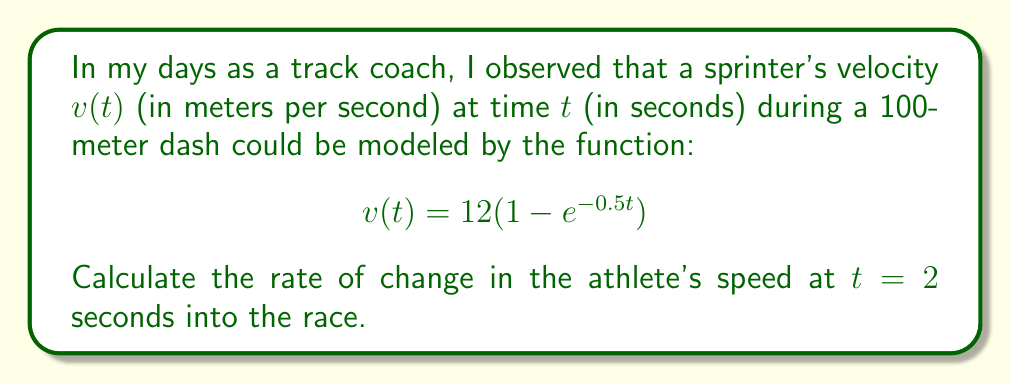Can you answer this question? To find the rate of change in the athlete's speed at $t = 2$ seconds, we need to calculate the derivative of the velocity function $v(t)$ and evaluate it at $t = 2$.

Step 1: Find the derivative of $v(t)$.
$$\begin{align}
v(t) &= 12(1 - e^{-0.5t}) \\
\frac{dv}{dt} &= 12 \cdot \frac{d}{dt}(1 - e^{-0.5t}) \\
&= 12 \cdot (-1) \cdot (-0.5e^{-0.5t}) \\
&= 6e^{-0.5t}
\end{align}$$

Step 2: Evaluate $\frac{dv}{dt}$ at $t = 2$.
$$\begin{align}
\frac{dv}{dt}\Big|_{t=2} &= 6e^{-0.5(2)} \\
&= 6e^{-1} \\
&\approx 2.21 \text{ m/s}^2
\end{align}$$

Therefore, the rate of change in the athlete's speed at $t = 2$ seconds is approximately 2.21 meters per second squared.
Answer: $2.21 \text{ m/s}^2$ 